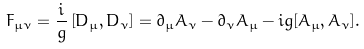<formula> <loc_0><loc_0><loc_500><loc_500>F _ { \mu \nu } = \frac { i } { g } \left [ D _ { \mu } , D _ { \nu } \right ] = \partial _ { \mu } A _ { \nu } - \partial _ { \nu } A _ { \mu } - i g [ A _ { \mu } , A _ { \nu } ] .</formula> 